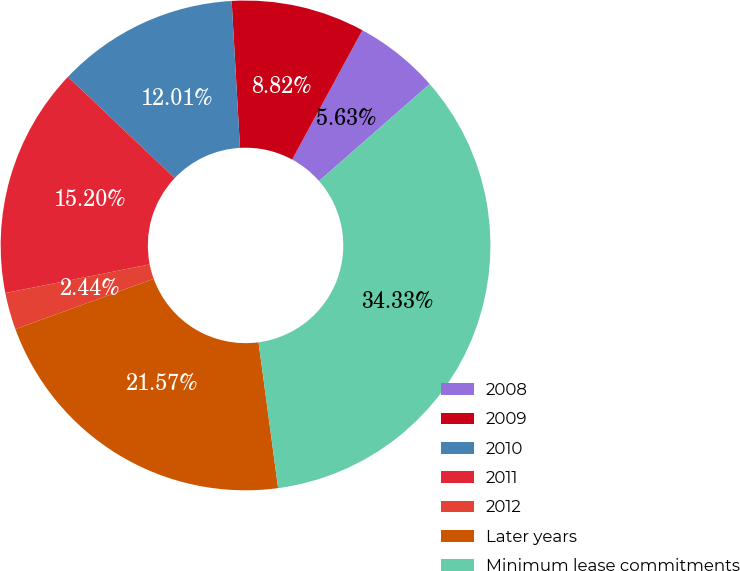Convert chart. <chart><loc_0><loc_0><loc_500><loc_500><pie_chart><fcel>2008<fcel>2009<fcel>2010<fcel>2011<fcel>2012<fcel>Later years<fcel>Minimum lease commitments<nl><fcel>5.63%<fcel>8.82%<fcel>12.01%<fcel>15.2%<fcel>2.44%<fcel>21.57%<fcel>34.33%<nl></chart> 